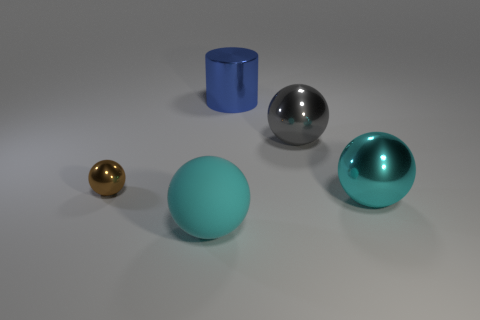How many gray things have the same size as the cylinder?
Give a very brief answer. 1. The large cyan object that is left of the cyan sphere behind the big object left of the big blue cylinder is made of what material?
Make the answer very short. Rubber. How many objects are either cyan matte spheres or small objects?
Provide a succinct answer. 2. Is there anything else that is made of the same material as the brown thing?
Make the answer very short. Yes. What shape is the tiny metallic thing?
Your answer should be very brief. Sphere. What is the shape of the thing that is to the left of the cyan thing that is to the left of the large cylinder?
Your answer should be compact. Sphere. Is the big cyan sphere right of the large blue shiny thing made of the same material as the small brown object?
Provide a succinct answer. Yes. How many blue objects are either metal spheres or rubber objects?
Offer a terse response. 0. Is there a big cylinder of the same color as the tiny object?
Provide a short and direct response. No. Is there a small thing that has the same material as the big cylinder?
Make the answer very short. Yes. 